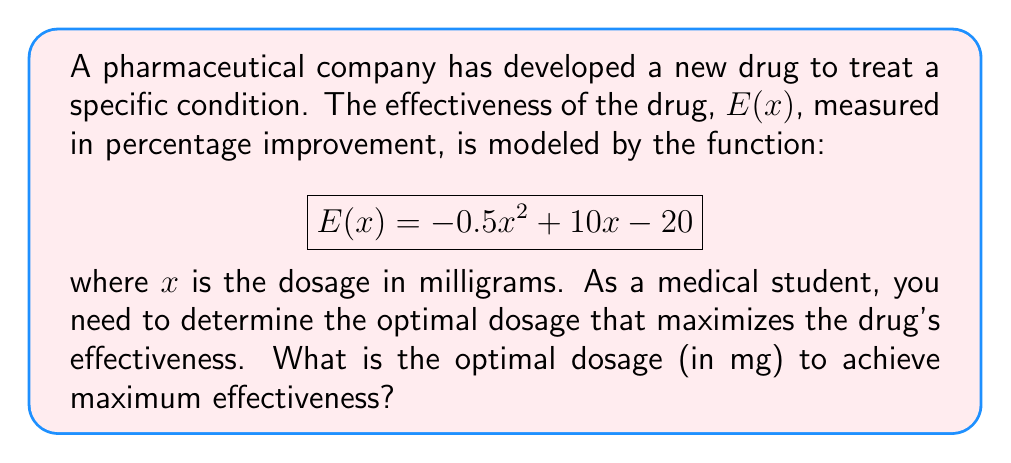Can you answer this question? To find the optimal dosage, we need to maximize the effectiveness function E(x). This is an optimization problem that can be solved using calculus.

Step 1: Find the derivative of E(x).
$$\frac{d}{dx}E(x) = \frac{d}{dx}(-0.5x^2 + 10x - 20)$$
$$E'(x) = -x + 10$$

Step 2: Set the derivative equal to zero to find critical points.
$$E'(x) = 0$$
$$-x + 10 = 0$$
$$x = 10$$

Step 3: Verify that this critical point is a maximum by checking the second derivative.
$$E''(x) = \frac{d}{dx}E'(x) = \frac{d}{dx}(-x + 10) = -1$$

Since E''(x) is negative, the critical point x = 10 is indeed a maximum.

Step 4: Confirm that this is a global maximum within the domain.
Since the function is a quadratic with a negative leading coefficient, it opens downward and has only one maximum point. Therefore, x = 10 is the global maximum.

Thus, the optimal dosage is 10 mg.
Answer: 10 mg 